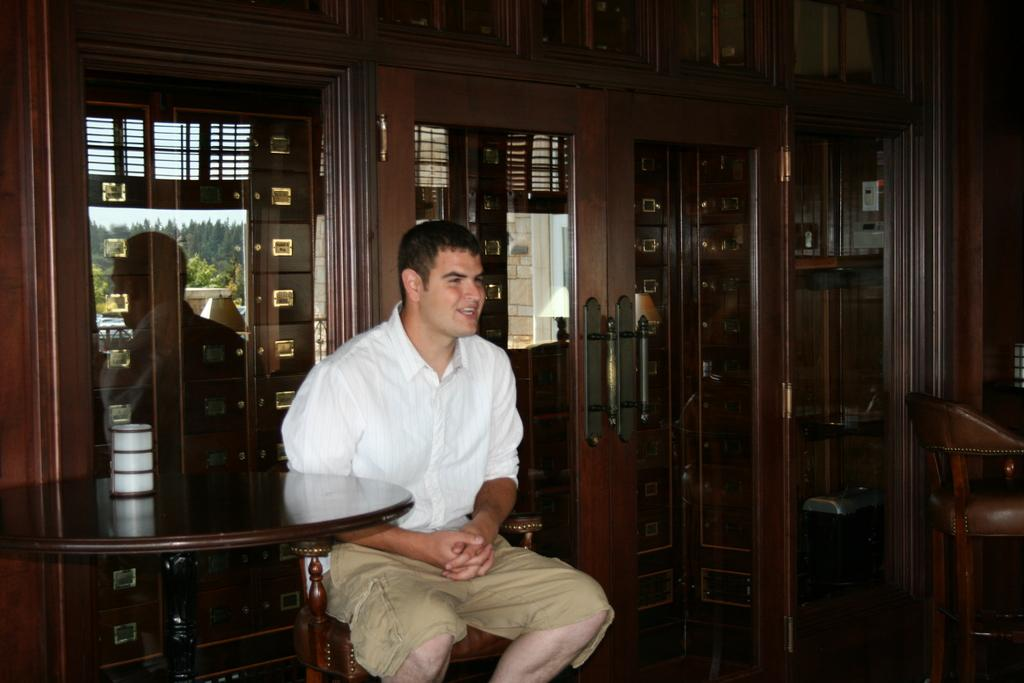Who is present in the image? There is a man in the image. What is the man doing in the image? The man is sitting on a chair. What other object can be seen in the image? There is a table in the image. What type of mask is the man wearing in the image? There is no mask present in the image; the man is not wearing any mask. 